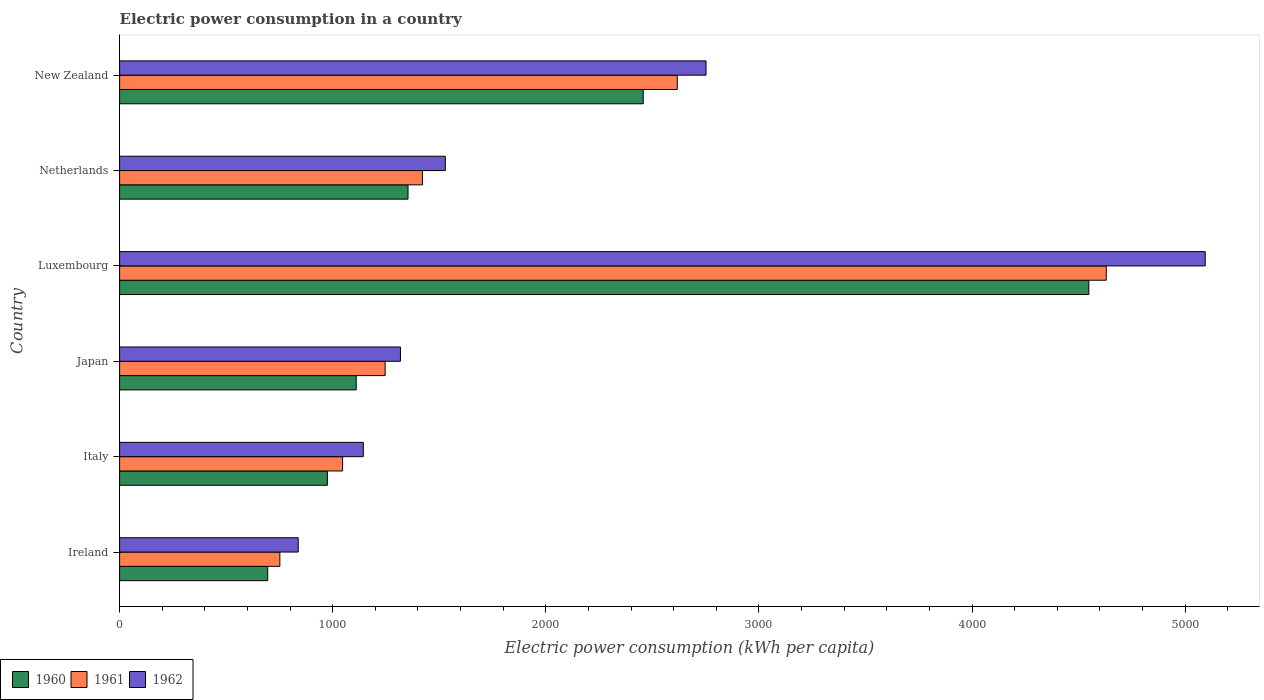How many groups of bars are there?
Your answer should be very brief. 6. Are the number of bars per tick equal to the number of legend labels?
Provide a short and direct response. Yes. Are the number of bars on each tick of the Y-axis equal?
Provide a succinct answer. Yes. How many bars are there on the 1st tick from the top?
Provide a succinct answer. 3. How many bars are there on the 1st tick from the bottom?
Provide a succinct answer. 3. What is the electric power consumption in in 1960 in Netherlands?
Your response must be concise. 1353.4. Across all countries, what is the maximum electric power consumption in in 1960?
Your answer should be compact. 4548.21. Across all countries, what is the minimum electric power consumption in in 1960?
Keep it short and to the point. 695.04. In which country was the electric power consumption in in 1960 maximum?
Provide a short and direct response. Luxembourg. In which country was the electric power consumption in in 1961 minimum?
Your answer should be compact. Ireland. What is the total electric power consumption in in 1960 in the graph?
Your answer should be compact. 1.11e+04. What is the difference between the electric power consumption in in 1962 in Italy and that in Luxembourg?
Offer a terse response. -3950.71. What is the difference between the electric power consumption in in 1961 in Luxembourg and the electric power consumption in in 1962 in Ireland?
Give a very brief answer. 3791.89. What is the average electric power consumption in in 1961 per country?
Your response must be concise. 1952.06. What is the difference between the electric power consumption in in 1961 and electric power consumption in in 1962 in New Zealand?
Offer a terse response. -134.96. What is the ratio of the electric power consumption in in 1962 in Japan to that in New Zealand?
Offer a very short reply. 0.48. What is the difference between the highest and the second highest electric power consumption in in 1961?
Provide a succinct answer. 2013.17. What is the difference between the highest and the lowest electric power consumption in in 1961?
Provide a succinct answer. 3878.01. In how many countries, is the electric power consumption in in 1961 greater than the average electric power consumption in in 1961 taken over all countries?
Provide a short and direct response. 2. What does the 1st bar from the top in Netherlands represents?
Give a very brief answer. 1962. Are all the bars in the graph horizontal?
Offer a very short reply. Yes. How many countries are there in the graph?
Your answer should be very brief. 6. What is the difference between two consecutive major ticks on the X-axis?
Offer a very short reply. 1000. Are the values on the major ticks of X-axis written in scientific E-notation?
Offer a very short reply. No. Does the graph contain grids?
Keep it short and to the point. No. What is the title of the graph?
Offer a very short reply. Electric power consumption in a country. Does "2005" appear as one of the legend labels in the graph?
Your response must be concise. No. What is the label or title of the X-axis?
Offer a very short reply. Electric power consumption (kWh per capita). What is the label or title of the Y-axis?
Provide a succinct answer. Country. What is the Electric power consumption (kWh per capita) of 1960 in Ireland?
Offer a very short reply. 695.04. What is the Electric power consumption (kWh per capita) in 1961 in Ireland?
Your answer should be compact. 752.02. What is the Electric power consumption (kWh per capita) of 1962 in Ireland?
Your answer should be very brief. 838.14. What is the Electric power consumption (kWh per capita) of 1960 in Italy?
Your answer should be very brief. 975.03. What is the Electric power consumption (kWh per capita) of 1961 in Italy?
Give a very brief answer. 1046.42. What is the Electric power consumption (kWh per capita) of 1962 in Italy?
Offer a very short reply. 1143.61. What is the Electric power consumption (kWh per capita) in 1960 in Japan?
Make the answer very short. 1110.26. What is the Electric power consumption (kWh per capita) of 1961 in Japan?
Keep it short and to the point. 1246.01. What is the Electric power consumption (kWh per capita) of 1962 in Japan?
Your answer should be compact. 1317.93. What is the Electric power consumption (kWh per capita) of 1960 in Luxembourg?
Provide a succinct answer. 4548.21. What is the Electric power consumption (kWh per capita) of 1961 in Luxembourg?
Your response must be concise. 4630.02. What is the Electric power consumption (kWh per capita) of 1962 in Luxembourg?
Make the answer very short. 5094.31. What is the Electric power consumption (kWh per capita) of 1960 in Netherlands?
Your answer should be compact. 1353.4. What is the Electric power consumption (kWh per capita) of 1961 in Netherlands?
Make the answer very short. 1421.03. What is the Electric power consumption (kWh per capita) of 1962 in Netherlands?
Give a very brief answer. 1528.5. What is the Electric power consumption (kWh per capita) in 1960 in New Zealand?
Make the answer very short. 2457.21. What is the Electric power consumption (kWh per capita) in 1961 in New Zealand?
Offer a very short reply. 2616.85. What is the Electric power consumption (kWh per capita) in 1962 in New Zealand?
Ensure brevity in your answer.  2751.81. Across all countries, what is the maximum Electric power consumption (kWh per capita) of 1960?
Give a very brief answer. 4548.21. Across all countries, what is the maximum Electric power consumption (kWh per capita) in 1961?
Ensure brevity in your answer.  4630.02. Across all countries, what is the maximum Electric power consumption (kWh per capita) in 1962?
Give a very brief answer. 5094.31. Across all countries, what is the minimum Electric power consumption (kWh per capita) of 1960?
Give a very brief answer. 695.04. Across all countries, what is the minimum Electric power consumption (kWh per capita) of 1961?
Your response must be concise. 752.02. Across all countries, what is the minimum Electric power consumption (kWh per capita) in 1962?
Your response must be concise. 838.14. What is the total Electric power consumption (kWh per capita) of 1960 in the graph?
Provide a short and direct response. 1.11e+04. What is the total Electric power consumption (kWh per capita) of 1961 in the graph?
Provide a short and direct response. 1.17e+04. What is the total Electric power consumption (kWh per capita) of 1962 in the graph?
Offer a terse response. 1.27e+04. What is the difference between the Electric power consumption (kWh per capita) in 1960 in Ireland and that in Italy?
Keep it short and to the point. -279.98. What is the difference between the Electric power consumption (kWh per capita) in 1961 in Ireland and that in Italy?
Offer a very short reply. -294.4. What is the difference between the Electric power consumption (kWh per capita) in 1962 in Ireland and that in Italy?
Offer a very short reply. -305.47. What is the difference between the Electric power consumption (kWh per capita) of 1960 in Ireland and that in Japan?
Provide a short and direct response. -415.22. What is the difference between the Electric power consumption (kWh per capita) of 1961 in Ireland and that in Japan?
Give a very brief answer. -493.99. What is the difference between the Electric power consumption (kWh per capita) in 1962 in Ireland and that in Japan?
Provide a short and direct response. -479.79. What is the difference between the Electric power consumption (kWh per capita) of 1960 in Ireland and that in Luxembourg?
Make the answer very short. -3853.16. What is the difference between the Electric power consumption (kWh per capita) of 1961 in Ireland and that in Luxembourg?
Provide a short and direct response. -3878.01. What is the difference between the Electric power consumption (kWh per capita) of 1962 in Ireland and that in Luxembourg?
Your answer should be compact. -4256.17. What is the difference between the Electric power consumption (kWh per capita) in 1960 in Ireland and that in Netherlands?
Make the answer very short. -658.36. What is the difference between the Electric power consumption (kWh per capita) of 1961 in Ireland and that in Netherlands?
Give a very brief answer. -669.02. What is the difference between the Electric power consumption (kWh per capita) of 1962 in Ireland and that in Netherlands?
Give a very brief answer. -690.36. What is the difference between the Electric power consumption (kWh per capita) of 1960 in Ireland and that in New Zealand?
Ensure brevity in your answer.  -1762.16. What is the difference between the Electric power consumption (kWh per capita) in 1961 in Ireland and that in New Zealand?
Your answer should be compact. -1864.84. What is the difference between the Electric power consumption (kWh per capita) of 1962 in Ireland and that in New Zealand?
Your answer should be very brief. -1913.68. What is the difference between the Electric power consumption (kWh per capita) in 1960 in Italy and that in Japan?
Make the answer very short. -135.24. What is the difference between the Electric power consumption (kWh per capita) in 1961 in Italy and that in Japan?
Offer a terse response. -199.6. What is the difference between the Electric power consumption (kWh per capita) in 1962 in Italy and that in Japan?
Keep it short and to the point. -174.33. What is the difference between the Electric power consumption (kWh per capita) in 1960 in Italy and that in Luxembourg?
Your response must be concise. -3573.18. What is the difference between the Electric power consumption (kWh per capita) of 1961 in Italy and that in Luxembourg?
Keep it short and to the point. -3583.61. What is the difference between the Electric power consumption (kWh per capita) in 1962 in Italy and that in Luxembourg?
Provide a succinct answer. -3950.71. What is the difference between the Electric power consumption (kWh per capita) of 1960 in Italy and that in Netherlands?
Your answer should be very brief. -378.37. What is the difference between the Electric power consumption (kWh per capita) of 1961 in Italy and that in Netherlands?
Provide a succinct answer. -374.62. What is the difference between the Electric power consumption (kWh per capita) in 1962 in Italy and that in Netherlands?
Provide a short and direct response. -384.9. What is the difference between the Electric power consumption (kWh per capita) in 1960 in Italy and that in New Zealand?
Your answer should be compact. -1482.18. What is the difference between the Electric power consumption (kWh per capita) of 1961 in Italy and that in New Zealand?
Your answer should be compact. -1570.44. What is the difference between the Electric power consumption (kWh per capita) in 1962 in Italy and that in New Zealand?
Keep it short and to the point. -1608.21. What is the difference between the Electric power consumption (kWh per capita) in 1960 in Japan and that in Luxembourg?
Make the answer very short. -3437.94. What is the difference between the Electric power consumption (kWh per capita) of 1961 in Japan and that in Luxembourg?
Give a very brief answer. -3384.01. What is the difference between the Electric power consumption (kWh per capita) in 1962 in Japan and that in Luxembourg?
Offer a very short reply. -3776.38. What is the difference between the Electric power consumption (kWh per capita) in 1960 in Japan and that in Netherlands?
Provide a short and direct response. -243.14. What is the difference between the Electric power consumption (kWh per capita) of 1961 in Japan and that in Netherlands?
Ensure brevity in your answer.  -175.02. What is the difference between the Electric power consumption (kWh per capita) of 1962 in Japan and that in Netherlands?
Offer a very short reply. -210.57. What is the difference between the Electric power consumption (kWh per capita) in 1960 in Japan and that in New Zealand?
Your response must be concise. -1346.94. What is the difference between the Electric power consumption (kWh per capita) of 1961 in Japan and that in New Zealand?
Offer a very short reply. -1370.84. What is the difference between the Electric power consumption (kWh per capita) of 1962 in Japan and that in New Zealand?
Provide a short and direct response. -1433.88. What is the difference between the Electric power consumption (kWh per capita) in 1960 in Luxembourg and that in Netherlands?
Provide a succinct answer. 3194.81. What is the difference between the Electric power consumption (kWh per capita) of 1961 in Luxembourg and that in Netherlands?
Your answer should be very brief. 3208.99. What is the difference between the Electric power consumption (kWh per capita) of 1962 in Luxembourg and that in Netherlands?
Ensure brevity in your answer.  3565.81. What is the difference between the Electric power consumption (kWh per capita) of 1960 in Luxembourg and that in New Zealand?
Offer a very short reply. 2091. What is the difference between the Electric power consumption (kWh per capita) of 1961 in Luxembourg and that in New Zealand?
Make the answer very short. 2013.17. What is the difference between the Electric power consumption (kWh per capita) in 1962 in Luxembourg and that in New Zealand?
Offer a terse response. 2342.5. What is the difference between the Electric power consumption (kWh per capita) of 1960 in Netherlands and that in New Zealand?
Offer a very short reply. -1103.81. What is the difference between the Electric power consumption (kWh per capita) of 1961 in Netherlands and that in New Zealand?
Offer a very short reply. -1195.82. What is the difference between the Electric power consumption (kWh per capita) in 1962 in Netherlands and that in New Zealand?
Give a very brief answer. -1223.31. What is the difference between the Electric power consumption (kWh per capita) of 1960 in Ireland and the Electric power consumption (kWh per capita) of 1961 in Italy?
Offer a very short reply. -351.37. What is the difference between the Electric power consumption (kWh per capita) in 1960 in Ireland and the Electric power consumption (kWh per capita) in 1962 in Italy?
Ensure brevity in your answer.  -448.56. What is the difference between the Electric power consumption (kWh per capita) of 1961 in Ireland and the Electric power consumption (kWh per capita) of 1962 in Italy?
Keep it short and to the point. -391.59. What is the difference between the Electric power consumption (kWh per capita) in 1960 in Ireland and the Electric power consumption (kWh per capita) in 1961 in Japan?
Your answer should be compact. -550.97. What is the difference between the Electric power consumption (kWh per capita) in 1960 in Ireland and the Electric power consumption (kWh per capita) in 1962 in Japan?
Provide a succinct answer. -622.89. What is the difference between the Electric power consumption (kWh per capita) in 1961 in Ireland and the Electric power consumption (kWh per capita) in 1962 in Japan?
Your answer should be very brief. -565.91. What is the difference between the Electric power consumption (kWh per capita) of 1960 in Ireland and the Electric power consumption (kWh per capita) of 1961 in Luxembourg?
Your answer should be compact. -3934.98. What is the difference between the Electric power consumption (kWh per capita) of 1960 in Ireland and the Electric power consumption (kWh per capita) of 1962 in Luxembourg?
Provide a short and direct response. -4399.27. What is the difference between the Electric power consumption (kWh per capita) of 1961 in Ireland and the Electric power consumption (kWh per capita) of 1962 in Luxembourg?
Make the answer very short. -4342.29. What is the difference between the Electric power consumption (kWh per capita) in 1960 in Ireland and the Electric power consumption (kWh per capita) in 1961 in Netherlands?
Provide a succinct answer. -725.99. What is the difference between the Electric power consumption (kWh per capita) of 1960 in Ireland and the Electric power consumption (kWh per capita) of 1962 in Netherlands?
Your answer should be very brief. -833.46. What is the difference between the Electric power consumption (kWh per capita) of 1961 in Ireland and the Electric power consumption (kWh per capita) of 1962 in Netherlands?
Your answer should be very brief. -776.48. What is the difference between the Electric power consumption (kWh per capita) in 1960 in Ireland and the Electric power consumption (kWh per capita) in 1961 in New Zealand?
Make the answer very short. -1921.81. What is the difference between the Electric power consumption (kWh per capita) of 1960 in Ireland and the Electric power consumption (kWh per capita) of 1962 in New Zealand?
Ensure brevity in your answer.  -2056.77. What is the difference between the Electric power consumption (kWh per capita) of 1961 in Ireland and the Electric power consumption (kWh per capita) of 1962 in New Zealand?
Keep it short and to the point. -1999.79. What is the difference between the Electric power consumption (kWh per capita) in 1960 in Italy and the Electric power consumption (kWh per capita) in 1961 in Japan?
Your response must be concise. -270.99. What is the difference between the Electric power consumption (kWh per capita) of 1960 in Italy and the Electric power consumption (kWh per capita) of 1962 in Japan?
Provide a short and direct response. -342.91. What is the difference between the Electric power consumption (kWh per capita) in 1961 in Italy and the Electric power consumption (kWh per capita) in 1962 in Japan?
Give a very brief answer. -271.52. What is the difference between the Electric power consumption (kWh per capita) of 1960 in Italy and the Electric power consumption (kWh per capita) of 1961 in Luxembourg?
Offer a terse response. -3655. What is the difference between the Electric power consumption (kWh per capita) of 1960 in Italy and the Electric power consumption (kWh per capita) of 1962 in Luxembourg?
Provide a succinct answer. -4119.28. What is the difference between the Electric power consumption (kWh per capita) of 1961 in Italy and the Electric power consumption (kWh per capita) of 1962 in Luxembourg?
Your answer should be very brief. -4047.9. What is the difference between the Electric power consumption (kWh per capita) of 1960 in Italy and the Electric power consumption (kWh per capita) of 1961 in Netherlands?
Your answer should be compact. -446.01. What is the difference between the Electric power consumption (kWh per capita) in 1960 in Italy and the Electric power consumption (kWh per capita) in 1962 in Netherlands?
Ensure brevity in your answer.  -553.47. What is the difference between the Electric power consumption (kWh per capita) in 1961 in Italy and the Electric power consumption (kWh per capita) in 1962 in Netherlands?
Provide a succinct answer. -482.09. What is the difference between the Electric power consumption (kWh per capita) in 1960 in Italy and the Electric power consumption (kWh per capita) in 1961 in New Zealand?
Provide a short and direct response. -1641.83. What is the difference between the Electric power consumption (kWh per capita) of 1960 in Italy and the Electric power consumption (kWh per capita) of 1962 in New Zealand?
Provide a short and direct response. -1776.79. What is the difference between the Electric power consumption (kWh per capita) in 1961 in Italy and the Electric power consumption (kWh per capita) in 1962 in New Zealand?
Ensure brevity in your answer.  -1705.4. What is the difference between the Electric power consumption (kWh per capita) of 1960 in Japan and the Electric power consumption (kWh per capita) of 1961 in Luxembourg?
Provide a short and direct response. -3519.76. What is the difference between the Electric power consumption (kWh per capita) in 1960 in Japan and the Electric power consumption (kWh per capita) in 1962 in Luxembourg?
Provide a succinct answer. -3984.05. What is the difference between the Electric power consumption (kWh per capita) of 1961 in Japan and the Electric power consumption (kWh per capita) of 1962 in Luxembourg?
Your response must be concise. -3848.3. What is the difference between the Electric power consumption (kWh per capita) in 1960 in Japan and the Electric power consumption (kWh per capita) in 1961 in Netherlands?
Give a very brief answer. -310.77. What is the difference between the Electric power consumption (kWh per capita) in 1960 in Japan and the Electric power consumption (kWh per capita) in 1962 in Netherlands?
Give a very brief answer. -418.24. What is the difference between the Electric power consumption (kWh per capita) of 1961 in Japan and the Electric power consumption (kWh per capita) of 1962 in Netherlands?
Your answer should be compact. -282.49. What is the difference between the Electric power consumption (kWh per capita) of 1960 in Japan and the Electric power consumption (kWh per capita) of 1961 in New Zealand?
Keep it short and to the point. -1506.59. What is the difference between the Electric power consumption (kWh per capita) in 1960 in Japan and the Electric power consumption (kWh per capita) in 1962 in New Zealand?
Provide a succinct answer. -1641.55. What is the difference between the Electric power consumption (kWh per capita) in 1961 in Japan and the Electric power consumption (kWh per capita) in 1962 in New Zealand?
Give a very brief answer. -1505.8. What is the difference between the Electric power consumption (kWh per capita) in 1960 in Luxembourg and the Electric power consumption (kWh per capita) in 1961 in Netherlands?
Offer a terse response. 3127.17. What is the difference between the Electric power consumption (kWh per capita) in 1960 in Luxembourg and the Electric power consumption (kWh per capita) in 1962 in Netherlands?
Your response must be concise. 3019.7. What is the difference between the Electric power consumption (kWh per capita) in 1961 in Luxembourg and the Electric power consumption (kWh per capita) in 1962 in Netherlands?
Keep it short and to the point. 3101.52. What is the difference between the Electric power consumption (kWh per capita) in 1960 in Luxembourg and the Electric power consumption (kWh per capita) in 1961 in New Zealand?
Keep it short and to the point. 1931.35. What is the difference between the Electric power consumption (kWh per capita) of 1960 in Luxembourg and the Electric power consumption (kWh per capita) of 1962 in New Zealand?
Offer a very short reply. 1796.39. What is the difference between the Electric power consumption (kWh per capita) of 1961 in Luxembourg and the Electric power consumption (kWh per capita) of 1962 in New Zealand?
Your answer should be very brief. 1878.21. What is the difference between the Electric power consumption (kWh per capita) in 1960 in Netherlands and the Electric power consumption (kWh per capita) in 1961 in New Zealand?
Offer a very short reply. -1263.45. What is the difference between the Electric power consumption (kWh per capita) of 1960 in Netherlands and the Electric power consumption (kWh per capita) of 1962 in New Zealand?
Give a very brief answer. -1398.41. What is the difference between the Electric power consumption (kWh per capita) in 1961 in Netherlands and the Electric power consumption (kWh per capita) in 1962 in New Zealand?
Provide a succinct answer. -1330.78. What is the average Electric power consumption (kWh per capita) of 1960 per country?
Your response must be concise. 1856.52. What is the average Electric power consumption (kWh per capita) of 1961 per country?
Your answer should be compact. 1952.06. What is the average Electric power consumption (kWh per capita) of 1962 per country?
Your answer should be very brief. 2112.38. What is the difference between the Electric power consumption (kWh per capita) in 1960 and Electric power consumption (kWh per capita) in 1961 in Ireland?
Your answer should be very brief. -56.97. What is the difference between the Electric power consumption (kWh per capita) of 1960 and Electric power consumption (kWh per capita) of 1962 in Ireland?
Your answer should be very brief. -143.09. What is the difference between the Electric power consumption (kWh per capita) of 1961 and Electric power consumption (kWh per capita) of 1962 in Ireland?
Give a very brief answer. -86.12. What is the difference between the Electric power consumption (kWh per capita) in 1960 and Electric power consumption (kWh per capita) in 1961 in Italy?
Your answer should be very brief. -71.39. What is the difference between the Electric power consumption (kWh per capita) in 1960 and Electric power consumption (kWh per capita) in 1962 in Italy?
Offer a terse response. -168.58. What is the difference between the Electric power consumption (kWh per capita) of 1961 and Electric power consumption (kWh per capita) of 1962 in Italy?
Offer a terse response. -97.19. What is the difference between the Electric power consumption (kWh per capita) in 1960 and Electric power consumption (kWh per capita) in 1961 in Japan?
Ensure brevity in your answer.  -135.75. What is the difference between the Electric power consumption (kWh per capita) in 1960 and Electric power consumption (kWh per capita) in 1962 in Japan?
Keep it short and to the point. -207.67. What is the difference between the Electric power consumption (kWh per capita) in 1961 and Electric power consumption (kWh per capita) in 1962 in Japan?
Provide a short and direct response. -71.92. What is the difference between the Electric power consumption (kWh per capita) in 1960 and Electric power consumption (kWh per capita) in 1961 in Luxembourg?
Your response must be concise. -81.82. What is the difference between the Electric power consumption (kWh per capita) in 1960 and Electric power consumption (kWh per capita) in 1962 in Luxembourg?
Give a very brief answer. -546.11. What is the difference between the Electric power consumption (kWh per capita) in 1961 and Electric power consumption (kWh per capita) in 1962 in Luxembourg?
Provide a succinct answer. -464.29. What is the difference between the Electric power consumption (kWh per capita) in 1960 and Electric power consumption (kWh per capita) in 1961 in Netherlands?
Offer a very short reply. -67.63. What is the difference between the Electric power consumption (kWh per capita) in 1960 and Electric power consumption (kWh per capita) in 1962 in Netherlands?
Ensure brevity in your answer.  -175.1. What is the difference between the Electric power consumption (kWh per capita) of 1961 and Electric power consumption (kWh per capita) of 1962 in Netherlands?
Ensure brevity in your answer.  -107.47. What is the difference between the Electric power consumption (kWh per capita) of 1960 and Electric power consumption (kWh per capita) of 1961 in New Zealand?
Your answer should be compact. -159.65. What is the difference between the Electric power consumption (kWh per capita) of 1960 and Electric power consumption (kWh per capita) of 1962 in New Zealand?
Give a very brief answer. -294.61. What is the difference between the Electric power consumption (kWh per capita) in 1961 and Electric power consumption (kWh per capita) in 1962 in New Zealand?
Keep it short and to the point. -134.96. What is the ratio of the Electric power consumption (kWh per capita) of 1960 in Ireland to that in Italy?
Make the answer very short. 0.71. What is the ratio of the Electric power consumption (kWh per capita) of 1961 in Ireland to that in Italy?
Offer a very short reply. 0.72. What is the ratio of the Electric power consumption (kWh per capita) in 1962 in Ireland to that in Italy?
Offer a terse response. 0.73. What is the ratio of the Electric power consumption (kWh per capita) of 1960 in Ireland to that in Japan?
Offer a terse response. 0.63. What is the ratio of the Electric power consumption (kWh per capita) in 1961 in Ireland to that in Japan?
Your answer should be compact. 0.6. What is the ratio of the Electric power consumption (kWh per capita) in 1962 in Ireland to that in Japan?
Your response must be concise. 0.64. What is the ratio of the Electric power consumption (kWh per capita) of 1960 in Ireland to that in Luxembourg?
Provide a short and direct response. 0.15. What is the ratio of the Electric power consumption (kWh per capita) of 1961 in Ireland to that in Luxembourg?
Offer a terse response. 0.16. What is the ratio of the Electric power consumption (kWh per capita) in 1962 in Ireland to that in Luxembourg?
Provide a short and direct response. 0.16. What is the ratio of the Electric power consumption (kWh per capita) in 1960 in Ireland to that in Netherlands?
Provide a short and direct response. 0.51. What is the ratio of the Electric power consumption (kWh per capita) of 1961 in Ireland to that in Netherlands?
Your response must be concise. 0.53. What is the ratio of the Electric power consumption (kWh per capita) in 1962 in Ireland to that in Netherlands?
Give a very brief answer. 0.55. What is the ratio of the Electric power consumption (kWh per capita) of 1960 in Ireland to that in New Zealand?
Your answer should be compact. 0.28. What is the ratio of the Electric power consumption (kWh per capita) in 1961 in Ireland to that in New Zealand?
Make the answer very short. 0.29. What is the ratio of the Electric power consumption (kWh per capita) of 1962 in Ireland to that in New Zealand?
Provide a short and direct response. 0.3. What is the ratio of the Electric power consumption (kWh per capita) of 1960 in Italy to that in Japan?
Ensure brevity in your answer.  0.88. What is the ratio of the Electric power consumption (kWh per capita) of 1961 in Italy to that in Japan?
Offer a terse response. 0.84. What is the ratio of the Electric power consumption (kWh per capita) in 1962 in Italy to that in Japan?
Give a very brief answer. 0.87. What is the ratio of the Electric power consumption (kWh per capita) in 1960 in Italy to that in Luxembourg?
Provide a succinct answer. 0.21. What is the ratio of the Electric power consumption (kWh per capita) of 1961 in Italy to that in Luxembourg?
Provide a short and direct response. 0.23. What is the ratio of the Electric power consumption (kWh per capita) of 1962 in Italy to that in Luxembourg?
Provide a succinct answer. 0.22. What is the ratio of the Electric power consumption (kWh per capita) in 1960 in Italy to that in Netherlands?
Your answer should be very brief. 0.72. What is the ratio of the Electric power consumption (kWh per capita) in 1961 in Italy to that in Netherlands?
Your answer should be very brief. 0.74. What is the ratio of the Electric power consumption (kWh per capita) of 1962 in Italy to that in Netherlands?
Provide a succinct answer. 0.75. What is the ratio of the Electric power consumption (kWh per capita) in 1960 in Italy to that in New Zealand?
Give a very brief answer. 0.4. What is the ratio of the Electric power consumption (kWh per capita) of 1961 in Italy to that in New Zealand?
Ensure brevity in your answer.  0.4. What is the ratio of the Electric power consumption (kWh per capita) in 1962 in Italy to that in New Zealand?
Ensure brevity in your answer.  0.42. What is the ratio of the Electric power consumption (kWh per capita) in 1960 in Japan to that in Luxembourg?
Your response must be concise. 0.24. What is the ratio of the Electric power consumption (kWh per capita) of 1961 in Japan to that in Luxembourg?
Provide a succinct answer. 0.27. What is the ratio of the Electric power consumption (kWh per capita) of 1962 in Japan to that in Luxembourg?
Give a very brief answer. 0.26. What is the ratio of the Electric power consumption (kWh per capita) in 1960 in Japan to that in Netherlands?
Ensure brevity in your answer.  0.82. What is the ratio of the Electric power consumption (kWh per capita) of 1961 in Japan to that in Netherlands?
Your response must be concise. 0.88. What is the ratio of the Electric power consumption (kWh per capita) in 1962 in Japan to that in Netherlands?
Ensure brevity in your answer.  0.86. What is the ratio of the Electric power consumption (kWh per capita) of 1960 in Japan to that in New Zealand?
Your answer should be very brief. 0.45. What is the ratio of the Electric power consumption (kWh per capita) in 1961 in Japan to that in New Zealand?
Ensure brevity in your answer.  0.48. What is the ratio of the Electric power consumption (kWh per capita) of 1962 in Japan to that in New Zealand?
Provide a succinct answer. 0.48. What is the ratio of the Electric power consumption (kWh per capita) of 1960 in Luxembourg to that in Netherlands?
Offer a very short reply. 3.36. What is the ratio of the Electric power consumption (kWh per capita) in 1961 in Luxembourg to that in Netherlands?
Offer a very short reply. 3.26. What is the ratio of the Electric power consumption (kWh per capita) in 1962 in Luxembourg to that in Netherlands?
Provide a succinct answer. 3.33. What is the ratio of the Electric power consumption (kWh per capita) of 1960 in Luxembourg to that in New Zealand?
Give a very brief answer. 1.85. What is the ratio of the Electric power consumption (kWh per capita) in 1961 in Luxembourg to that in New Zealand?
Ensure brevity in your answer.  1.77. What is the ratio of the Electric power consumption (kWh per capita) in 1962 in Luxembourg to that in New Zealand?
Provide a short and direct response. 1.85. What is the ratio of the Electric power consumption (kWh per capita) of 1960 in Netherlands to that in New Zealand?
Your response must be concise. 0.55. What is the ratio of the Electric power consumption (kWh per capita) in 1961 in Netherlands to that in New Zealand?
Offer a very short reply. 0.54. What is the ratio of the Electric power consumption (kWh per capita) of 1962 in Netherlands to that in New Zealand?
Your answer should be very brief. 0.56. What is the difference between the highest and the second highest Electric power consumption (kWh per capita) of 1960?
Provide a short and direct response. 2091. What is the difference between the highest and the second highest Electric power consumption (kWh per capita) in 1961?
Your response must be concise. 2013.17. What is the difference between the highest and the second highest Electric power consumption (kWh per capita) of 1962?
Your response must be concise. 2342.5. What is the difference between the highest and the lowest Electric power consumption (kWh per capita) in 1960?
Offer a very short reply. 3853.16. What is the difference between the highest and the lowest Electric power consumption (kWh per capita) of 1961?
Your answer should be compact. 3878.01. What is the difference between the highest and the lowest Electric power consumption (kWh per capita) in 1962?
Your response must be concise. 4256.17. 